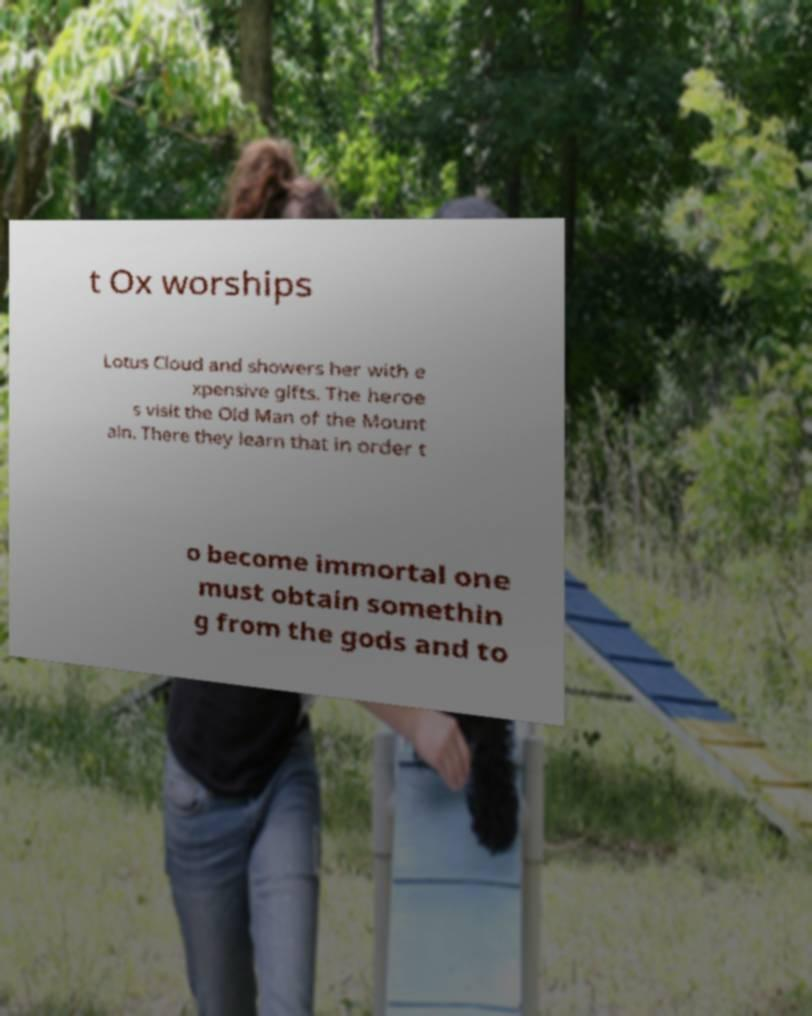For documentation purposes, I need the text within this image transcribed. Could you provide that? t Ox worships Lotus Cloud and showers her with e xpensive gifts. The heroe s visit the Old Man of the Mount ain. There they learn that in order t o become immortal one must obtain somethin g from the gods and to 